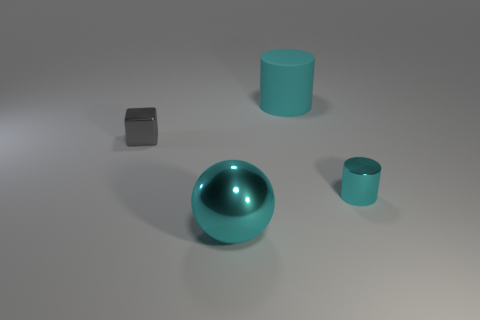Is there anything else that has the same shape as the gray metallic thing?
Your response must be concise. No. How many spheres are the same color as the large rubber thing?
Your response must be concise. 1. What number of things are objects on the right side of the metallic sphere or shiny objects?
Provide a short and direct response. 4. There is a cylinder that is the same material as the gray thing; what is its color?
Keep it short and to the point. Cyan. Is there a cyan shiny thing that has the same size as the gray block?
Provide a succinct answer. Yes. What number of things are either cyan metallic objects right of the matte cylinder or objects that are to the left of the big matte cylinder?
Your answer should be very brief. 3. There is a cyan rubber thing that is the same size as the sphere; what shape is it?
Give a very brief answer. Cylinder. Are there any other metallic things that have the same shape as the small gray object?
Offer a terse response. No. Is the number of tiny cyan metal cylinders less than the number of tiny red metal spheres?
Your answer should be compact. No. There is a ball that is in front of the small metallic cylinder; is its size the same as the cyan cylinder behind the small gray object?
Your answer should be compact. Yes. 